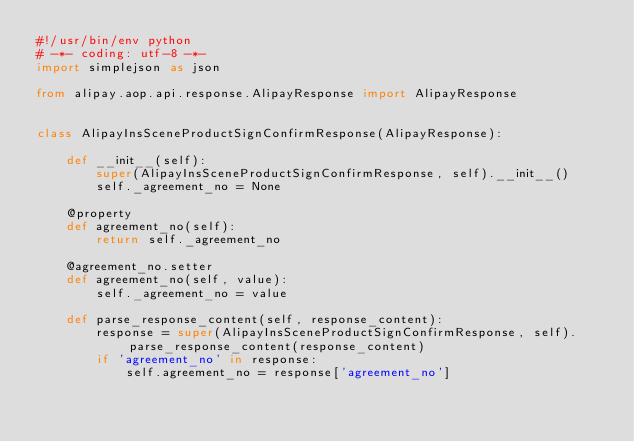<code> <loc_0><loc_0><loc_500><loc_500><_Python_>#!/usr/bin/env python
# -*- coding: utf-8 -*-
import simplejson as json

from alipay.aop.api.response.AlipayResponse import AlipayResponse


class AlipayInsSceneProductSignConfirmResponse(AlipayResponse):

    def __init__(self):
        super(AlipayInsSceneProductSignConfirmResponse, self).__init__()
        self._agreement_no = None

    @property
    def agreement_no(self):
        return self._agreement_no

    @agreement_no.setter
    def agreement_no(self, value):
        self._agreement_no = value

    def parse_response_content(self, response_content):
        response = super(AlipayInsSceneProductSignConfirmResponse, self).parse_response_content(response_content)
        if 'agreement_no' in response:
            self.agreement_no = response['agreement_no']
</code> 